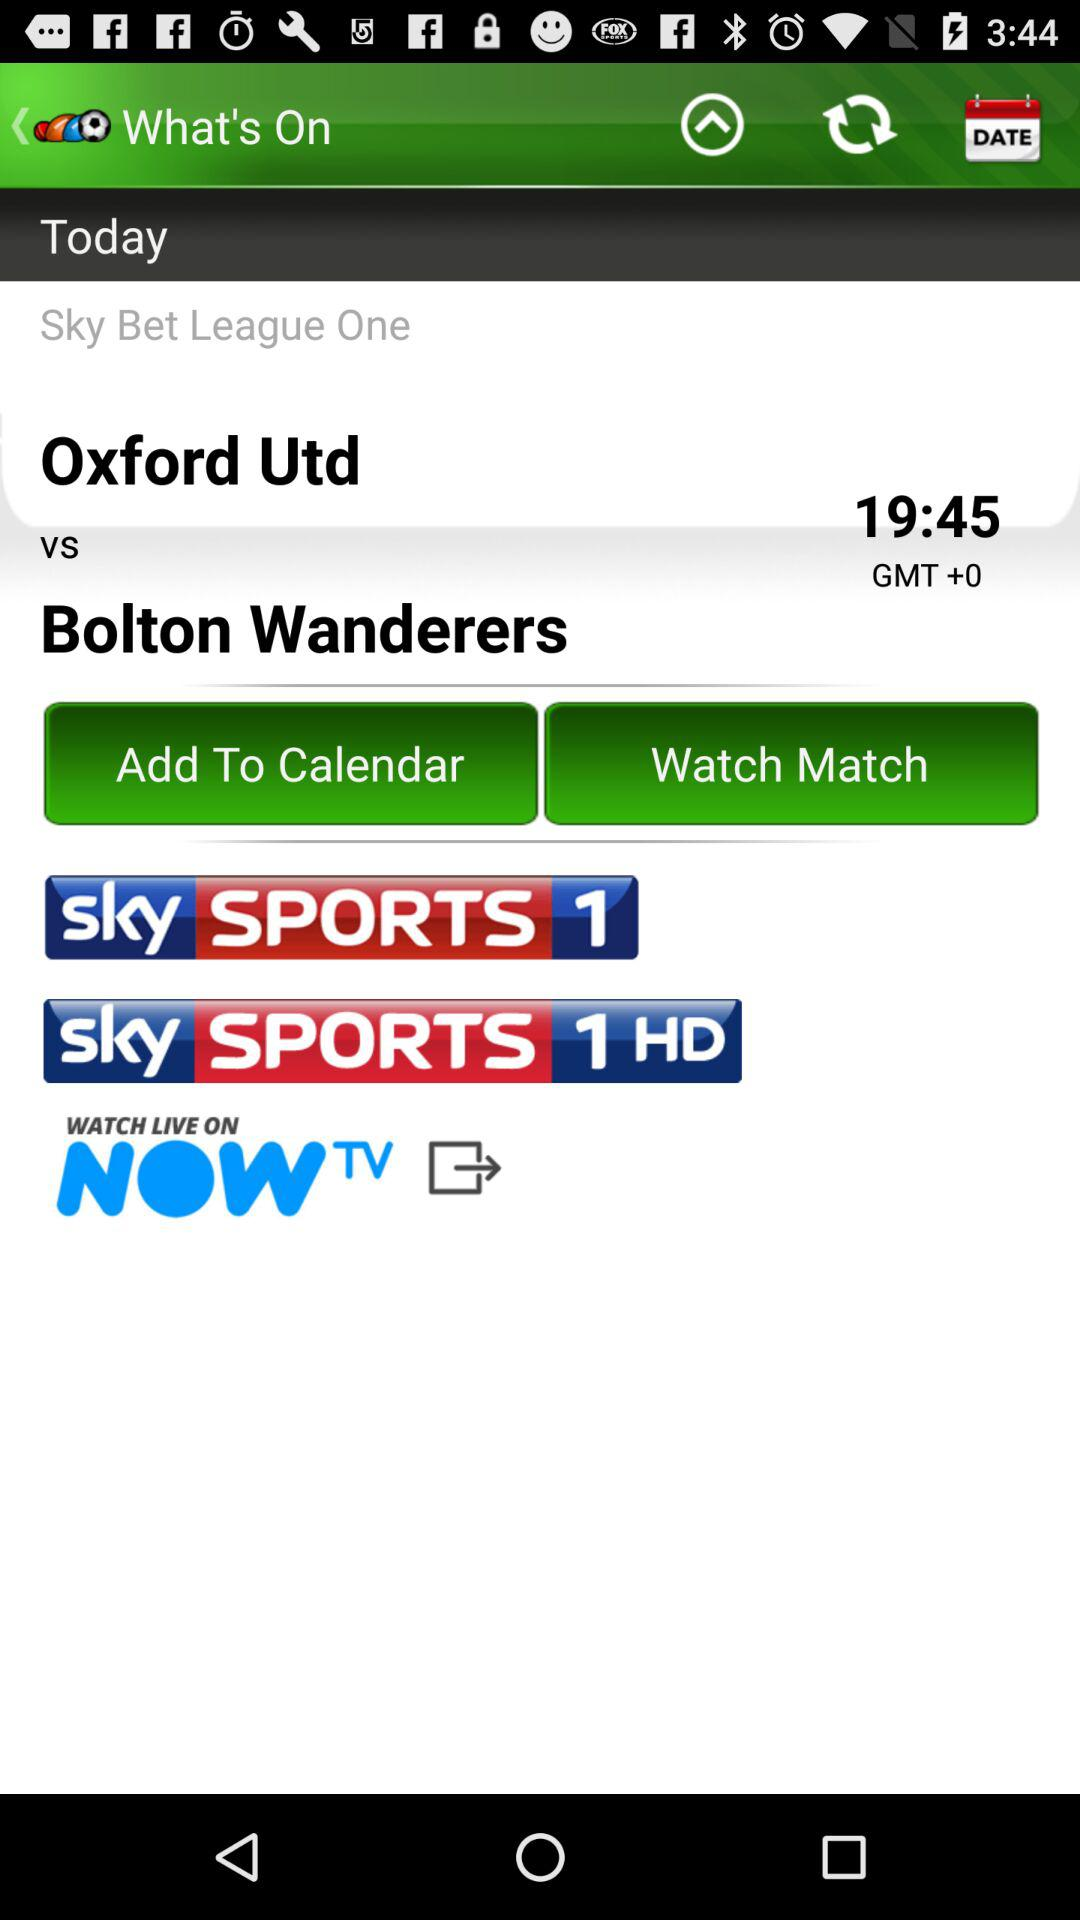How many sky sports channels are available to watch this match on?
Answer the question using a single word or phrase. 2 